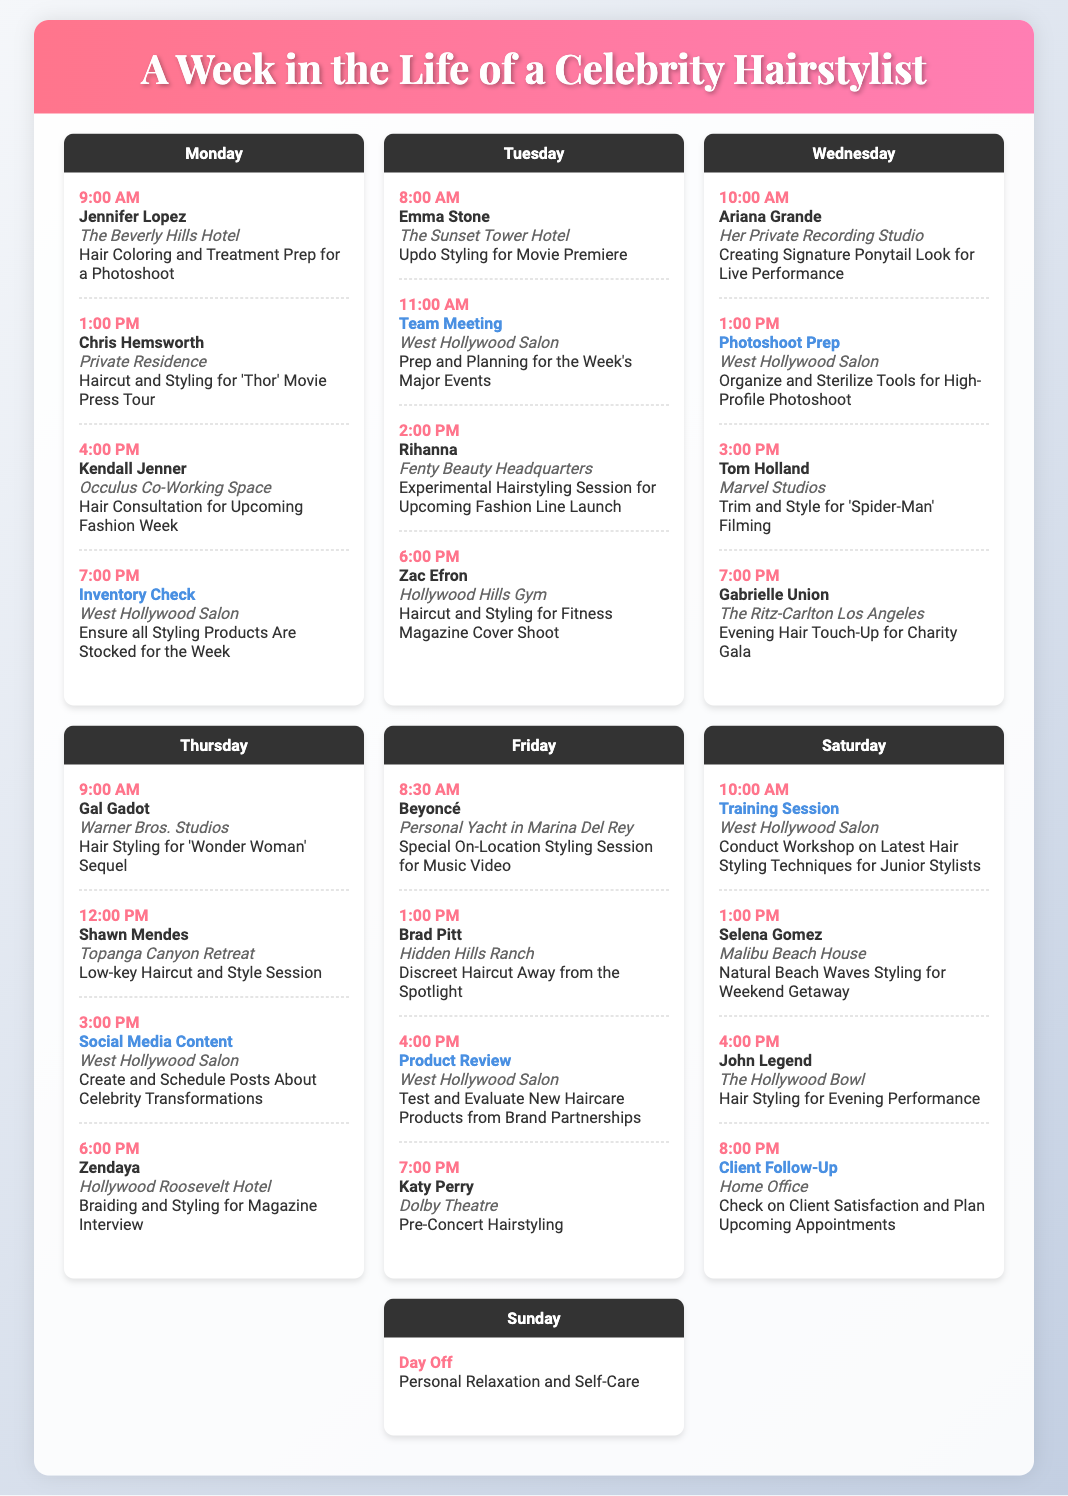What celebrity has an appointment at The Beverly Hills Hotel on Monday? The appointment on Monday at The Beverly Hills Hotel is with Jennifer Lopez.
Answer: Jennifer Lopez What time is the hair consultation with Kendall Jenner scheduled for on Monday? The hair consultation with Kendall Jenner is scheduled for 4:00 PM on Monday.
Answer: 4:00 PM Who is the client scheduled for an updo styling on Tuesday? The client scheduled for updo styling on Tuesday is Emma Stone.
Answer: Emma Stone How many client appointments are scheduled for Friday? There are four client appointments scheduled for Friday.
Answer: Four On which day is the training session for junior stylists taking place? The training session is taking place on Saturday.
Answer: Saturday What type of styling does Selena Gomez need for her weekend getaway? Selena Gomez needs natural beach waves styling for her weekend getaway.
Answer: Natural Beach Waves Styling Which client has a haircut appointment at a private residence? Chris Hemsworth has a haircut appointment at a private residence.
Answer: Chris Hemsworth What task is planned for Thursday at 3:00 PM? The task planned for Thursday at 3:00 PM is social media content creation.
Answer: Social Media Content Who is scheduled for a pre-concert hairstyling on Friday? Katy Perry is scheduled for pre-concert hairstyling on Friday.
Answer: Katy Perry 